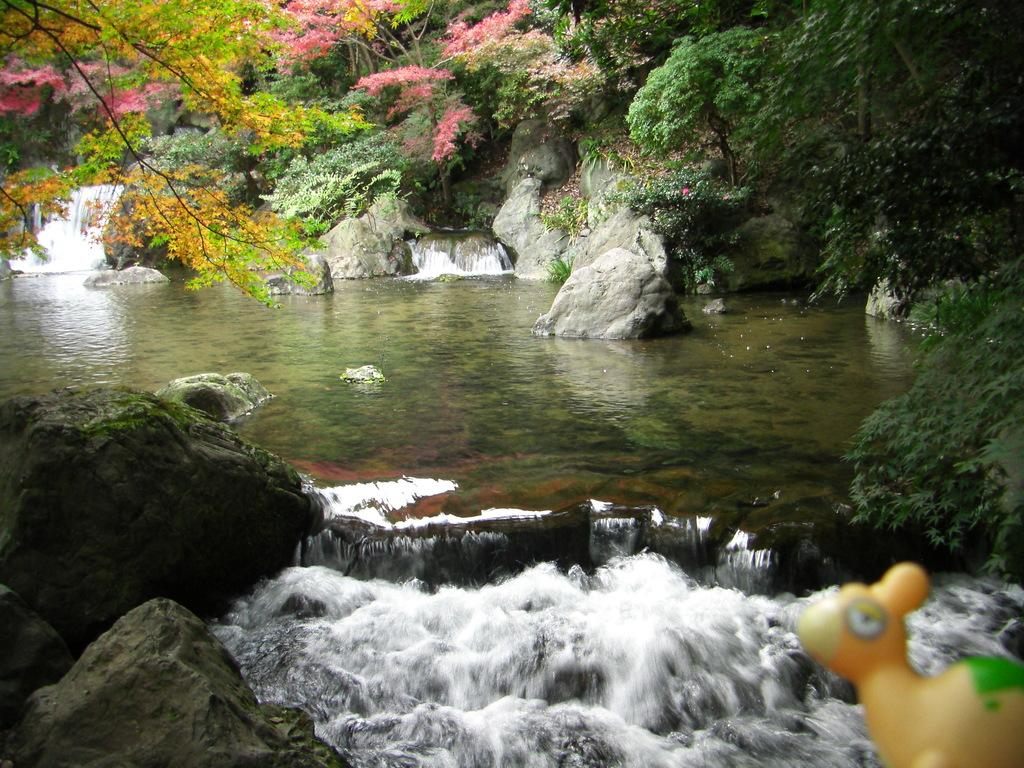What object can be found in the bottom right of the image? There is a toy in the bottom right of the image. What natural feature is visible at the bottom of the image? There is a water flow and rocks present at the bottom of the image. What body of water is in the middle of the image? There is a lake in the middle of the image. What geographical feature is visible in the middle of the image? A hill is visible in the middle of the image. What types of plants are present in the middle of the image? Trees and flowers are visible in the middle of the image. What type of yak can be seen resting on the hill in the image? There is no yak present in the image; it features a toy, a water flow, rocks, a lake, a hill, trees, and flowers. What decisions are being made by the committee in the image? There is no committee present in the image; it is a landscape featuring natural elements and a toy. 